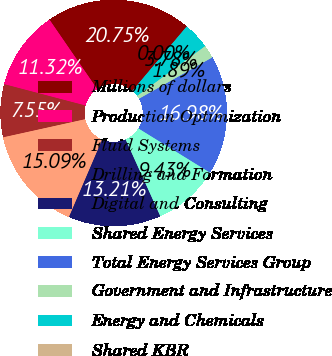<chart> <loc_0><loc_0><loc_500><loc_500><pie_chart><fcel>Millions of dollars<fcel>Production Optimization<fcel>Fluid Systems<fcel>Drilling and Formation<fcel>Digital and Consulting<fcel>Shared Energy Services<fcel>Total Energy Services Group<fcel>Government and Infrastructure<fcel>Energy and Chemicals<fcel>Shared KBR<nl><fcel>20.75%<fcel>11.32%<fcel>7.55%<fcel>15.09%<fcel>13.21%<fcel>9.43%<fcel>16.98%<fcel>1.89%<fcel>3.78%<fcel>0.0%<nl></chart> 